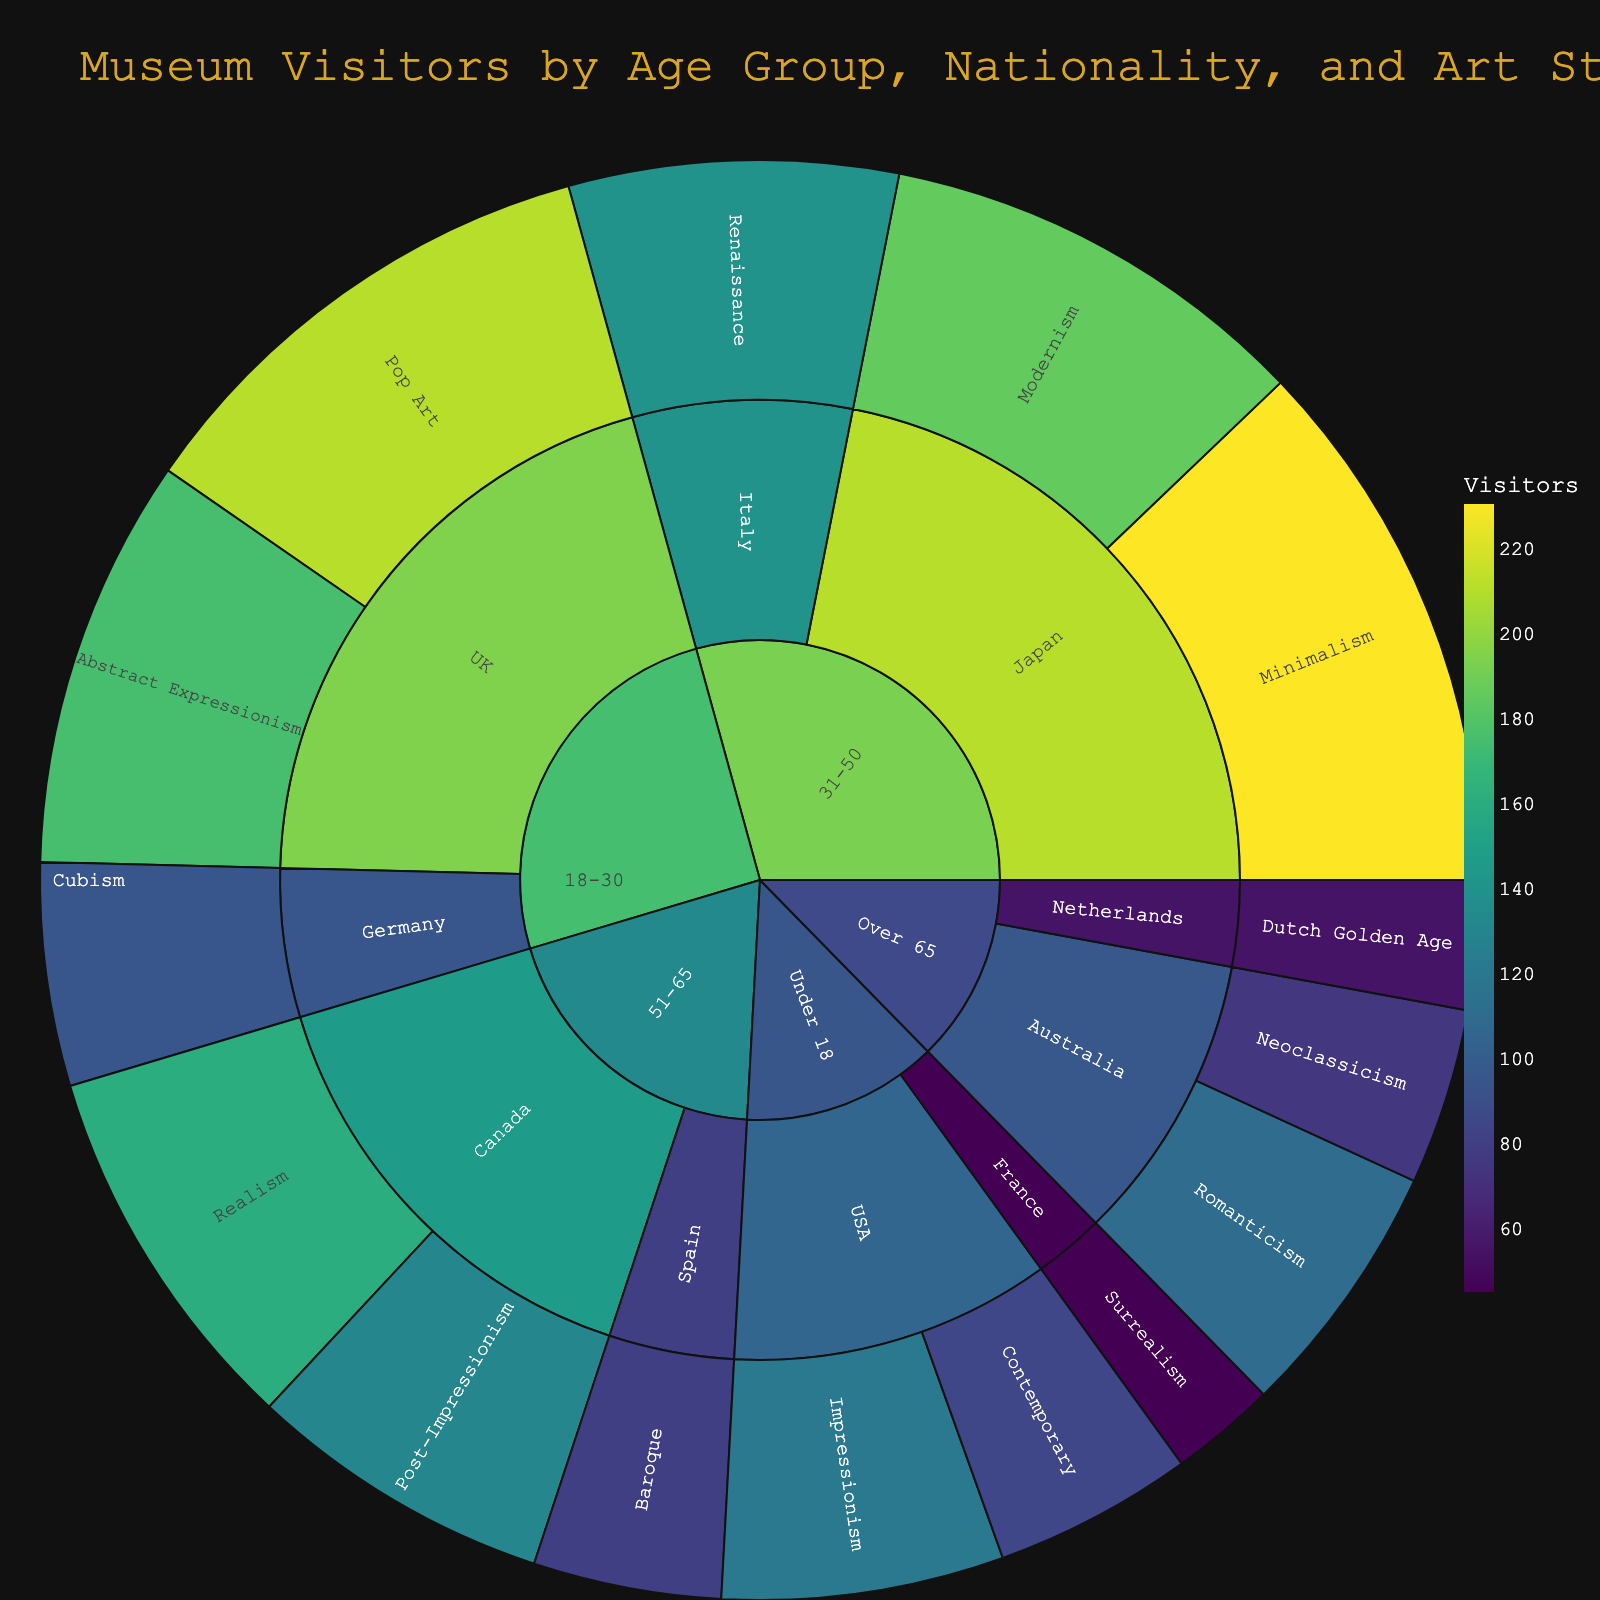What's the title of the plot? The title is located at the top of the plot, typically in larger and highlighted text. According to the code, the title should be "Museum Visitors by Age Group, Nationality, and Art Style".
Answer: Museum Visitors by Age Group, Nationality, and Art Style Which age group has the highest number of visitors? By looking at the different segments of the sunburst plot, the segment with the largest size represents the age group with the highest number of visitors.
Answer: 31-50 Which nationality has the fewest visitors in the 'Under 18' age group? Navigate to the 'Under 18' segment, and observe the segments for each nationality within this age group. The smallest one indicates the nationality with the fewest visitors.
Answer: France What's the total number of visitors interested in Contemporary art? Identify all segments tagged as Contemporary art across different age groups and nationalities, then sum the values. Here, the only segment with Contemporary art is within the 'Under 18' and 'USA', which has 85 visitors.
Answer: 85 How many visitors from Canada prefer Realism and Post-Impressionism combined? Locate the segments for Canada within the age group and sum the values for Realism and Post-Impressionism. The numbers are 160 for Realism and 130 for Post-Impressionism; 160 + 130 = 290.
Answer: 290 Compare visitors from UK and Germany in the '18-30' age group. Which nationality has more visitors and by how much? Find the visitors' segments for the UK and Germany within the '18-30' age group. Add up the totals for Pop Art (210) and Abstract Expressionism (175) in the UK and Cubism (95) in Germany: 210 + 175 = 385 for the UK; 385 - 95 = 290. The UK has 290 more visitors than Germany.
Answer: UK, by 290 Which age group has visitors interested in the Dutch Golden Age art style and how many are there? Look for the segment labeled Dutch Golden Age and follow the path to see its parent segments. The segment falls under 'Over 65' and 'Netherlands' with 55 visitors.
Answer: Over 65, 55 Which art style is the most preferred among the 31-50 age group? Compare the sizes of segments within the 31-50 age group and identify which segment is the largest, indicating the most preferred art style. The segment for Minimalism with 230 visitors is the largest.
Answer: Minimalism Which two age groups have the least disparity in the number of visitors? Calculate the total number of visitors for each age group and find the pair with the smallest difference. Basic sums: Under 18 (250), 18-30 (480), 31-50 (555), 51-65 (370), and Over 65 (240). The least disparity is between Under 18 and Over 65:
Answer: Under 18 and Over 65 In the '51-65' age group, which nationality prefers Baroque and how many visitors does it have? Look at the '51-65' age group segment and identify which nationality segment contains Baroque, which is within the Spanish nationality segment and has 80 visitors.
Answer: Spain, 80 